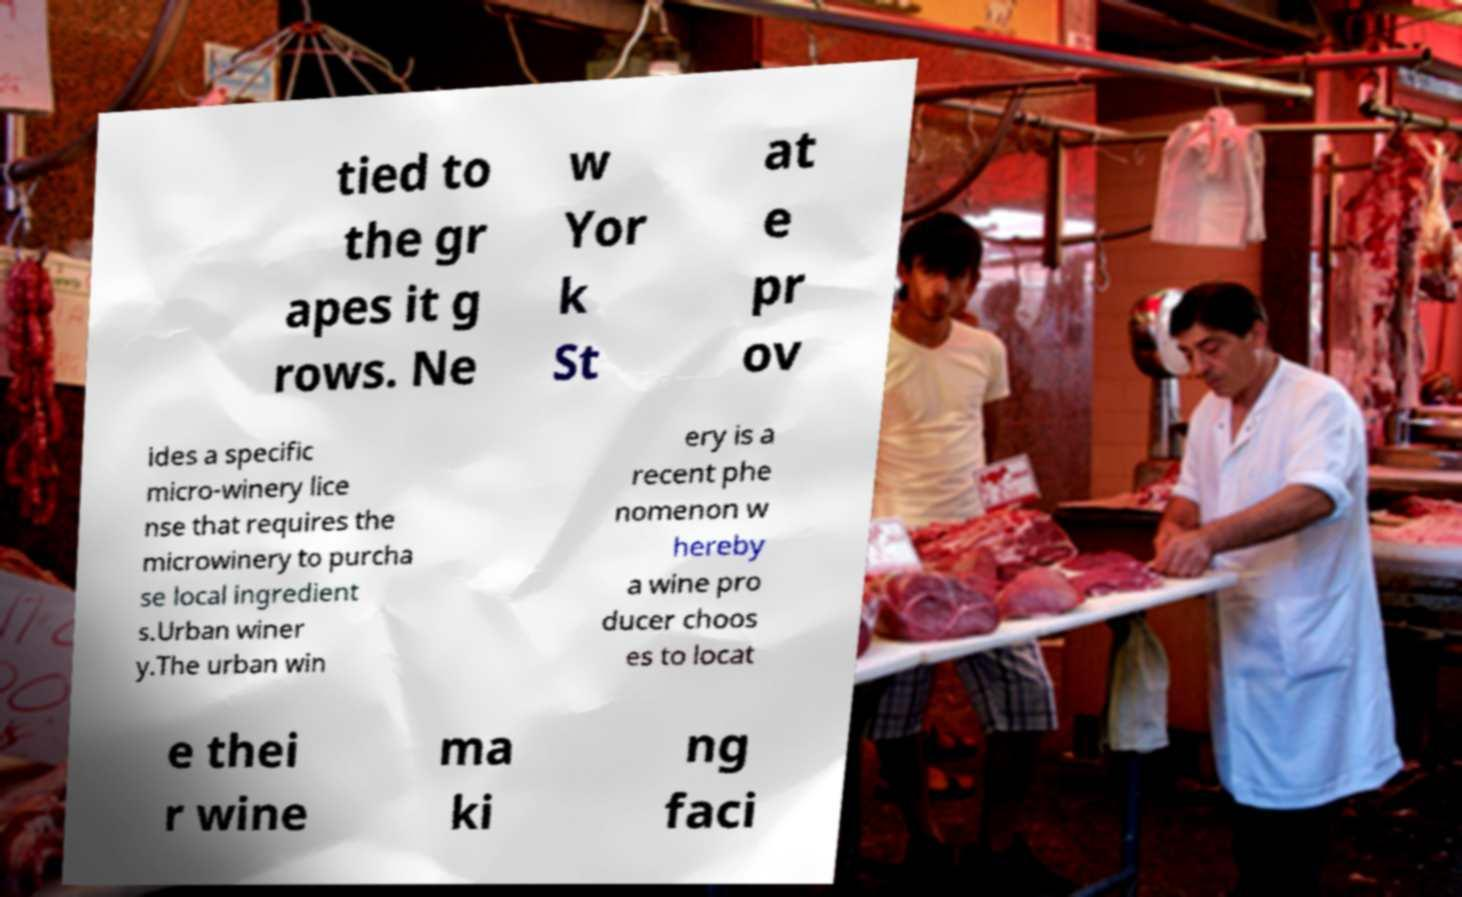There's text embedded in this image that I need extracted. Can you transcribe it verbatim? tied to the gr apes it g rows. Ne w Yor k St at e pr ov ides a specific micro-winery lice nse that requires the microwinery to purcha se local ingredient s.Urban winer y.The urban win ery is a recent phe nomenon w hereby a wine pro ducer choos es to locat e thei r wine ma ki ng faci 